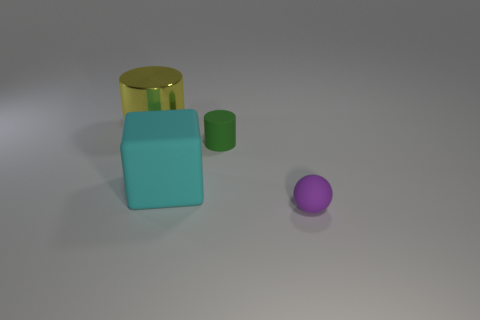Describe the arrangement of the objects. Do they form any recognisable pattern or shape? The objects are arranged somewhat randomly across a flat surface. They do not appear to form a specific pattern or shape when viewed as a group. 